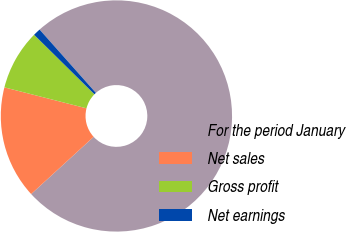Convert chart to OTSL. <chart><loc_0><loc_0><loc_500><loc_500><pie_chart><fcel>For the period January<fcel>Net sales<fcel>Gross profit<fcel>Net earnings<nl><fcel>74.76%<fcel>15.78%<fcel>8.41%<fcel>1.04%<nl></chart> 